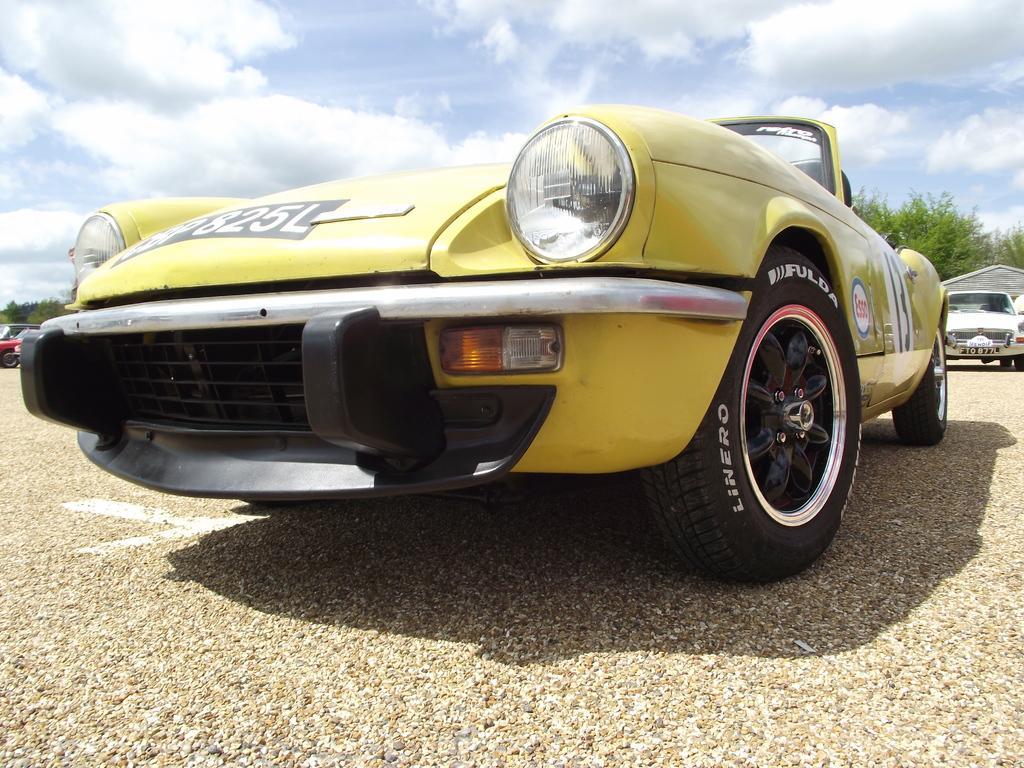Please provide a concise description of this image. In this image I can see few cars, trees, shadows, clouds, the sky and here on this car I can see something is written at few places. 